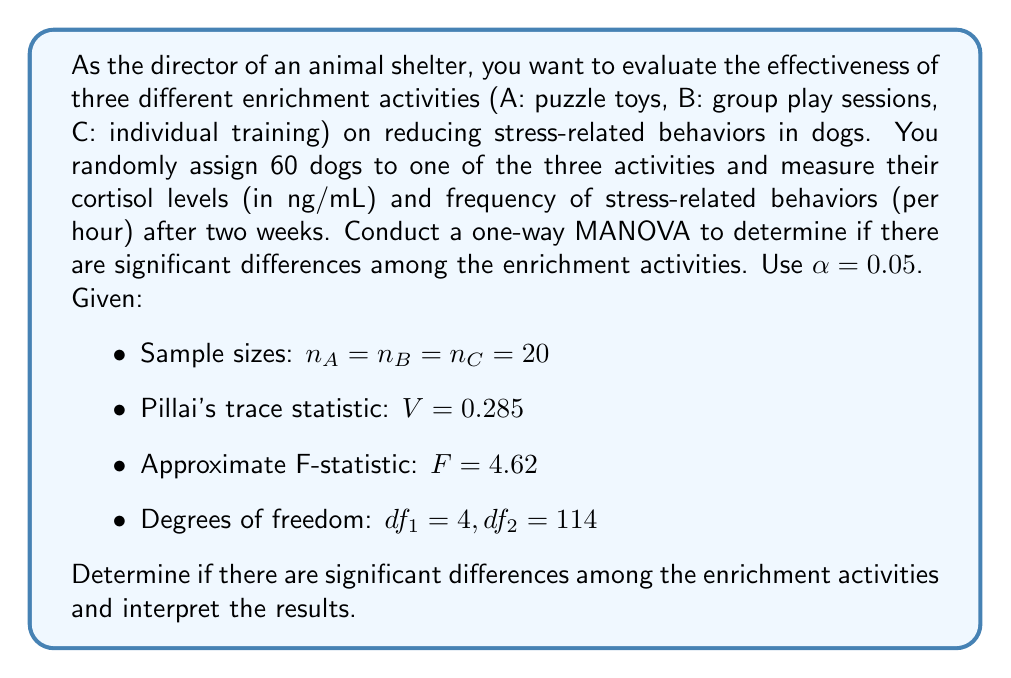Solve this math problem. To evaluate the effectiveness of different enrichment activities using MANOVA, we follow these steps:

1. State the hypotheses:
   $H_0$: There are no significant differences in the linear combination of cortisol levels and stress-related behaviors among the three enrichment activities.
   $H_a$: There are significant differences in the linear combination of cortisol levels and stress-related behaviors among the three enrichment activities.

2. Check the test statistic and critical value:
   - We are given Pillai's trace statistic $V = 0.285$ and the approximate F-statistic $F = 4.62$
   - Degrees of freedom: $df_1 = 4, df_2 = 114$
   - α = 0.05

3. Find the critical F-value:
   $F_{crit} = F_{0.05, 4, 114} ≈ 2.45$ (obtained from F-distribution table or calculator)

4. Compare the test statistic to the critical value:
   $F = 4.62 > F_{crit} = 2.45$

5. Calculate the p-value:
   The p-value can be found using an F-distribution calculator or table. In this case, p-value < 0.05

6. Make a decision:
   Since $F > F_{crit}$ and p-value < α, we reject the null hypothesis.

7. Interpret the results:
   There is sufficient evidence to conclude that there are significant differences in the linear combination of cortisol levels and stress-related behaviors among the three enrichment activities (puzzle toys, group play sessions, and individual training) at the 0.05 significance level.

This result suggests that the type of enrichment activity has a significant effect on the combined measure of cortisol levels and frequency of stress-related behaviors in shelter dogs. However, to determine which specific activities differ from each other and in which dependent variables, follow-up analyses such as univariate ANOVAs or discriminant analysis would be necessary.
Answer: Reject $H_0$. There are significant differences in the linear combination of cortisol levels and stress-related behaviors among the three enrichment activities (F = 4.62, df = 4, 114, p < 0.05). 